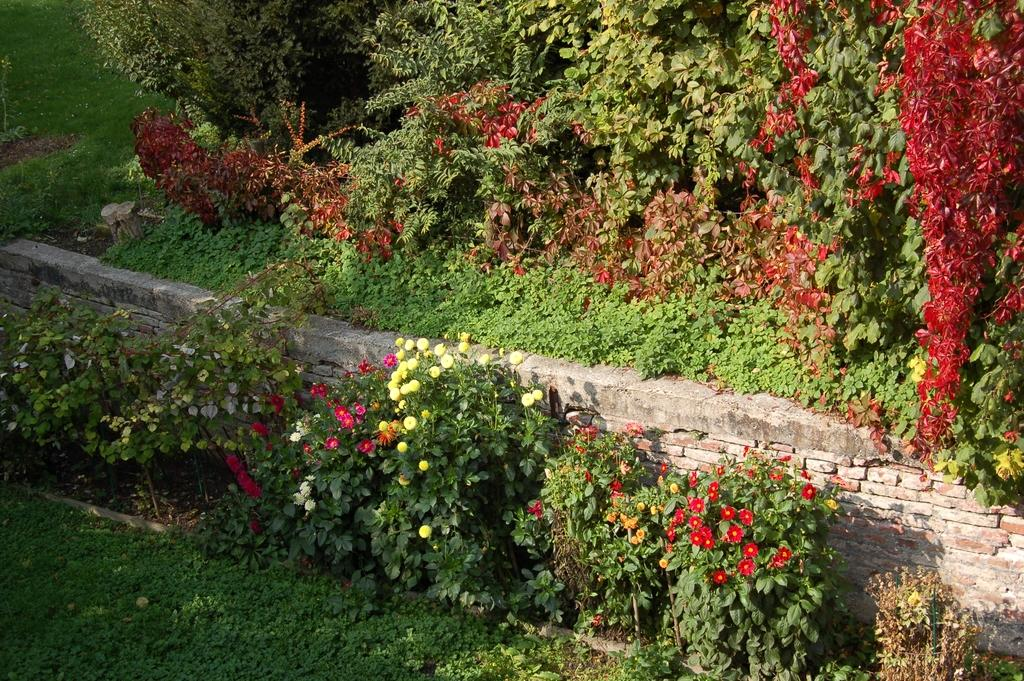What type of plants can be seen in the image? There are plants with flowers in the image. What is located behind the plants? There is a wall, trees, and grass behind the plants. How many pigs are visible in the image? There are no pigs present in the image. Did the earthquake cause any damage to the plants in the image? There is no mention of an earthquake in the image or the provided facts, so we cannot determine if it caused any damage. 